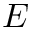<formula> <loc_0><loc_0><loc_500><loc_500>E</formula> 